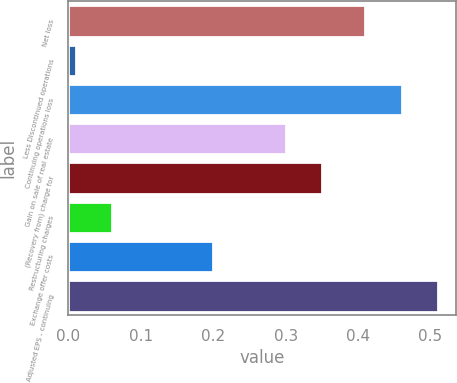Convert chart to OTSL. <chart><loc_0><loc_0><loc_500><loc_500><bar_chart><fcel>Net loss<fcel>Less Discontinued operations<fcel>Continuing operations loss<fcel>Gain on sale of real estate<fcel>(Recovery from) charge for<fcel>Restructuring charges<fcel>Exchange offer costs<fcel>Adjusted EPS - continuing<nl><fcel>0.41<fcel>0.01<fcel>0.46<fcel>0.3<fcel>0.35<fcel>0.06<fcel>0.2<fcel>0.51<nl></chart> 